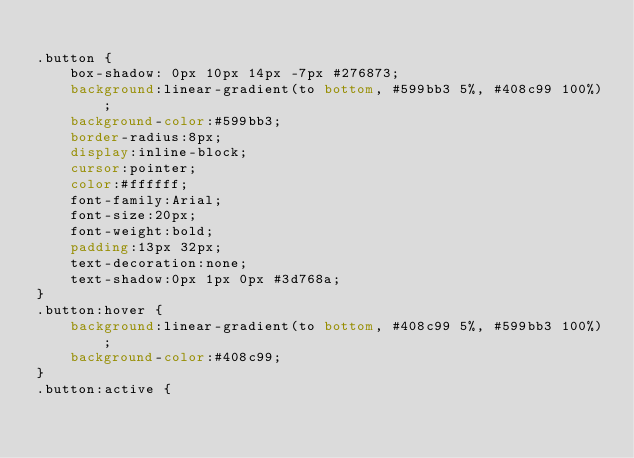<code> <loc_0><loc_0><loc_500><loc_500><_CSS_>
.button {
	box-shadow: 0px 10px 14px -7px #276873;
	background:linear-gradient(to bottom, #599bb3 5%, #408c99 100%);
	background-color:#599bb3;
	border-radius:8px;
	display:inline-block;
	cursor:pointer;
	color:#ffffff;
	font-family:Arial;
	font-size:20px;
	font-weight:bold;
	padding:13px 32px;
	text-decoration:none;
	text-shadow:0px 1px 0px #3d768a;
}
.button:hover {
	background:linear-gradient(to bottom, #408c99 5%, #599bb3 100%);
	background-color:#408c99;
}
.button:active {</code> 